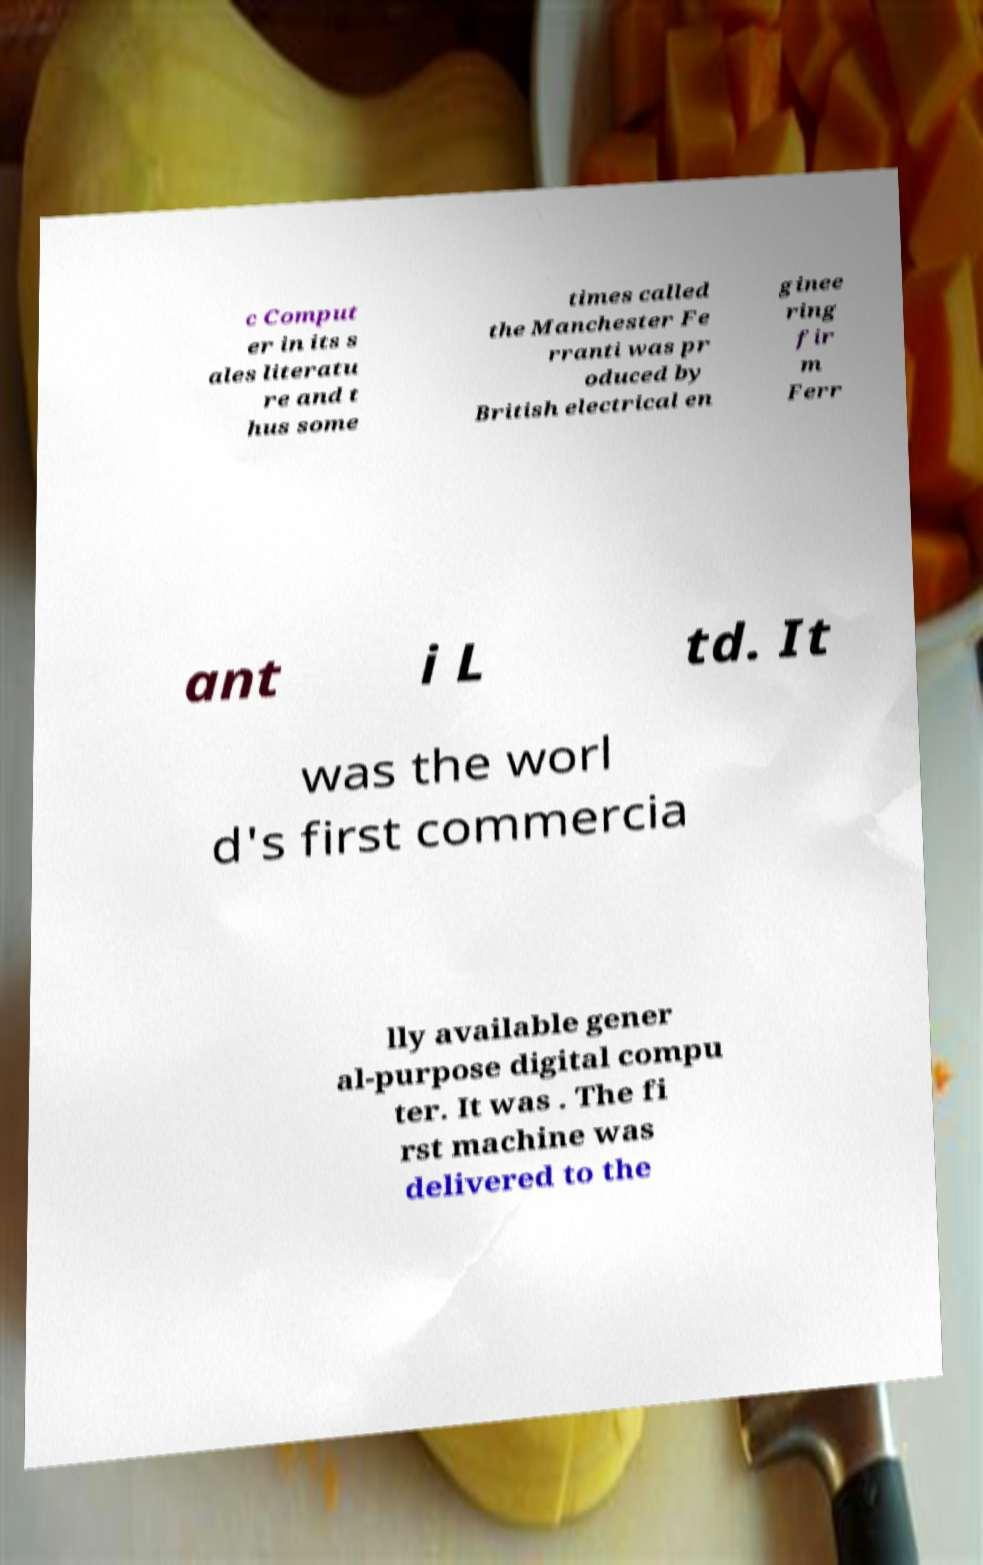Please read and relay the text visible in this image. What does it say? c Comput er in its s ales literatu re and t hus some times called the Manchester Fe rranti was pr oduced by British electrical en ginee ring fir m Ferr ant i L td. It was the worl d's first commercia lly available gener al-purpose digital compu ter. It was . The fi rst machine was delivered to the 